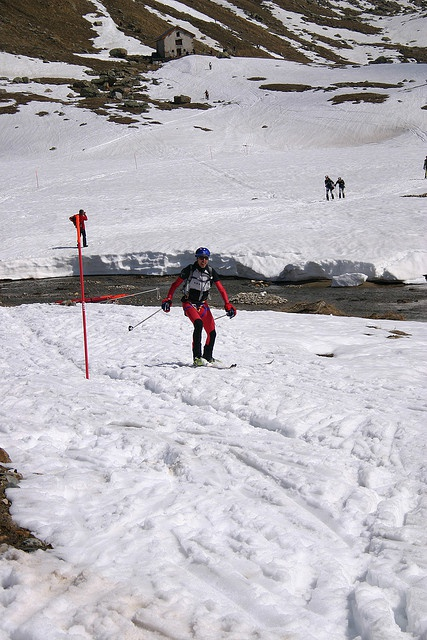Describe the objects in this image and their specific colors. I can see people in black, maroon, gray, and brown tones, people in black, maroon, and gray tones, skis in black, lightgray, darkgray, and gray tones, people in black, lightgray, gray, and darkgray tones, and people in black, gray, darkgray, and lightgray tones in this image. 